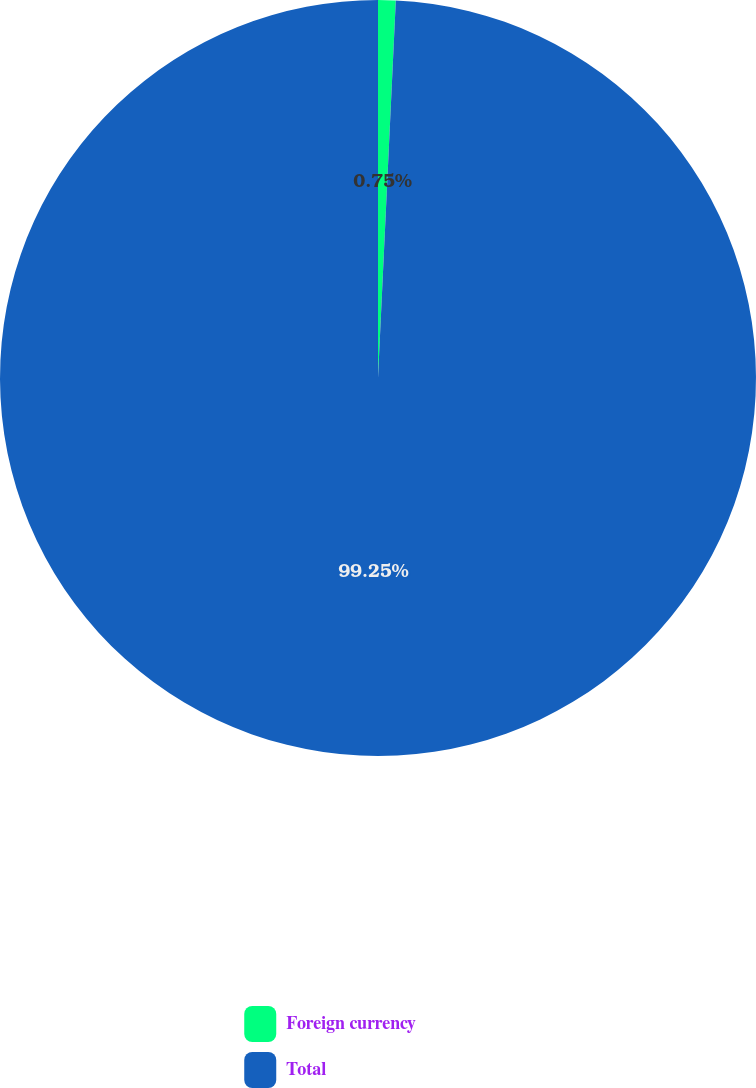Convert chart. <chart><loc_0><loc_0><loc_500><loc_500><pie_chart><fcel>Foreign currency<fcel>Total<nl><fcel>0.75%<fcel>99.25%<nl></chart> 